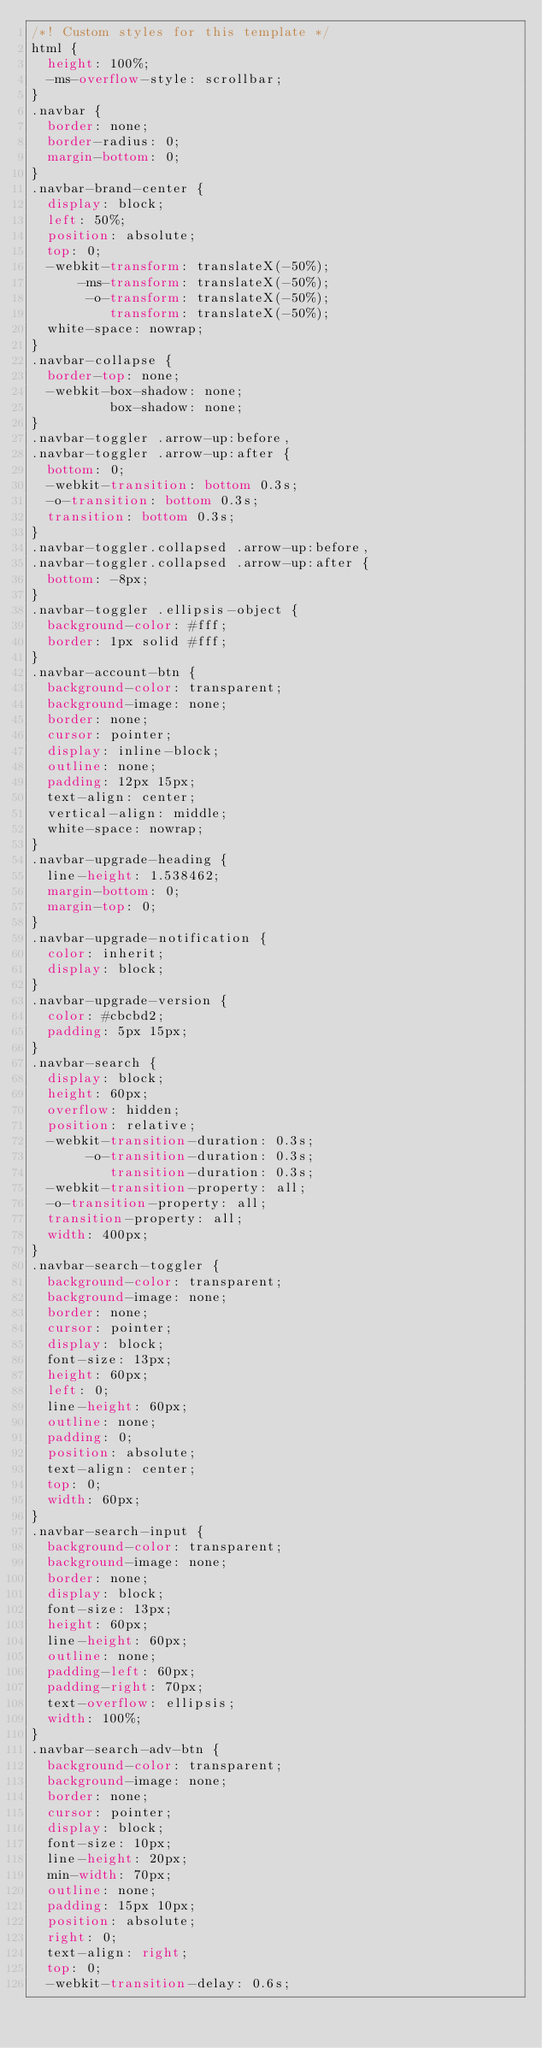Convert code to text. <code><loc_0><loc_0><loc_500><loc_500><_CSS_>/*! Custom styles for this template */
html {
  height: 100%;
  -ms-overflow-style: scrollbar;
}
.navbar {
  border: none;
  border-radius: 0;
  margin-bottom: 0;
}
.navbar-brand-center {
  display: block;
  left: 50%;
  position: absolute;
  top: 0;
  -webkit-transform: translateX(-50%);
      -ms-transform: translateX(-50%);
       -o-transform: translateX(-50%);
          transform: translateX(-50%);
  white-space: nowrap;
}
.navbar-collapse {
  border-top: none;
  -webkit-box-shadow: none;
          box-shadow: none;
}
.navbar-toggler .arrow-up:before,
.navbar-toggler .arrow-up:after {
  bottom: 0;
  -webkit-transition: bottom 0.3s;
  -o-transition: bottom 0.3s;
  transition: bottom 0.3s;
}
.navbar-toggler.collapsed .arrow-up:before,
.navbar-toggler.collapsed .arrow-up:after {
  bottom: -8px;
}
.navbar-toggler .ellipsis-object {
  background-color: #fff;
  border: 1px solid #fff;
}
.navbar-account-btn {
  background-color: transparent;
  background-image: none;
  border: none;
  cursor: pointer;
  display: inline-block;
  outline: none;
  padding: 12px 15px;
  text-align: center;
  vertical-align: middle;
  white-space: nowrap;
}
.navbar-upgrade-heading {
  line-height: 1.538462;
  margin-bottom: 0;
  margin-top: 0;
}
.navbar-upgrade-notification {
  color: inherit;
  display: block;
}
.navbar-upgrade-version {
  color: #cbcbd2;
  padding: 5px 15px;
}
.navbar-search {
  display: block;
  height: 60px;
  overflow: hidden;
  position: relative;
  -webkit-transition-duration: 0.3s;
       -o-transition-duration: 0.3s;
          transition-duration: 0.3s;
  -webkit-transition-property: all;
  -o-transition-property: all;
  transition-property: all;
  width: 400px;
}
.navbar-search-toggler {
  background-color: transparent;
  background-image: none;
  border: none;
  cursor: pointer;
  display: block;
  font-size: 13px;
  height: 60px;
  left: 0;
  line-height: 60px;
  outline: none;
  padding: 0;
  position: absolute;
  text-align: center;
  top: 0;
  width: 60px;
}
.navbar-search-input {
  background-color: transparent;
  background-image: none;
  border: none;
  display: block;
  font-size: 13px;
  height: 60px;
  line-height: 60px;
  outline: none;
  padding-left: 60px;
  padding-right: 70px;
  text-overflow: ellipsis;
  width: 100%;
}
.navbar-search-adv-btn {
  background-color: transparent;
  background-image: none;
  border: none;
  cursor: pointer;
  display: block;
  font-size: 10px;
  line-height: 20px;
  min-width: 70px;
  outline: none;
  padding: 15px 10px;
  position: absolute;
  right: 0;
  text-align: right;
  top: 0;
  -webkit-transition-delay: 0.6s;</code> 